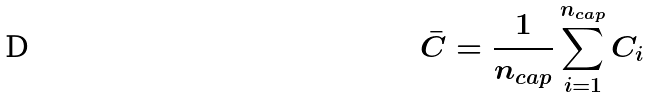<formula> <loc_0><loc_0><loc_500><loc_500>\bar { C } = \frac { 1 } { n _ { c a p } } \sum _ { i = 1 } ^ { n _ { c a p } } C _ { i }</formula> 